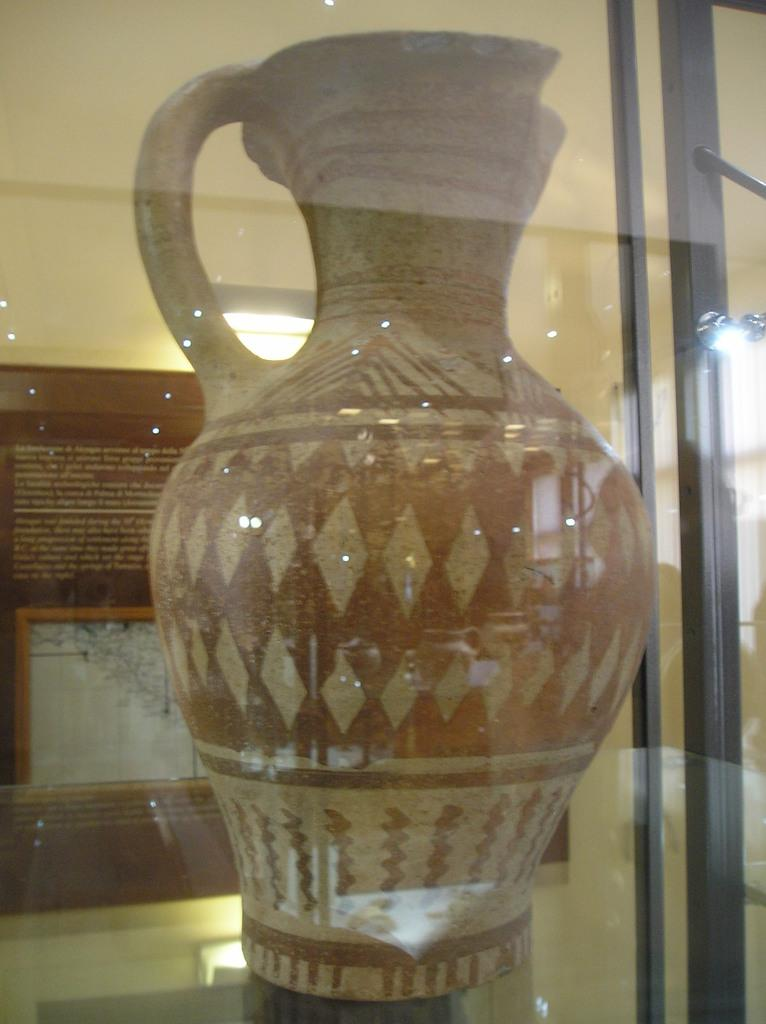What is the main object in the middle of the image? There is a pot in the middle of the image. Where is the pot placed? The pot is on a surface. How is the pot covered? The pot is covered with a glass. What can be seen in the background of the image? There is a board, a light, and a wall in the background of the image. What type of comfort can be seen in the image? There is no reference to comfort in the image; it features a pot covered with a glass on a surface, with a board, light, and wall in the background. 